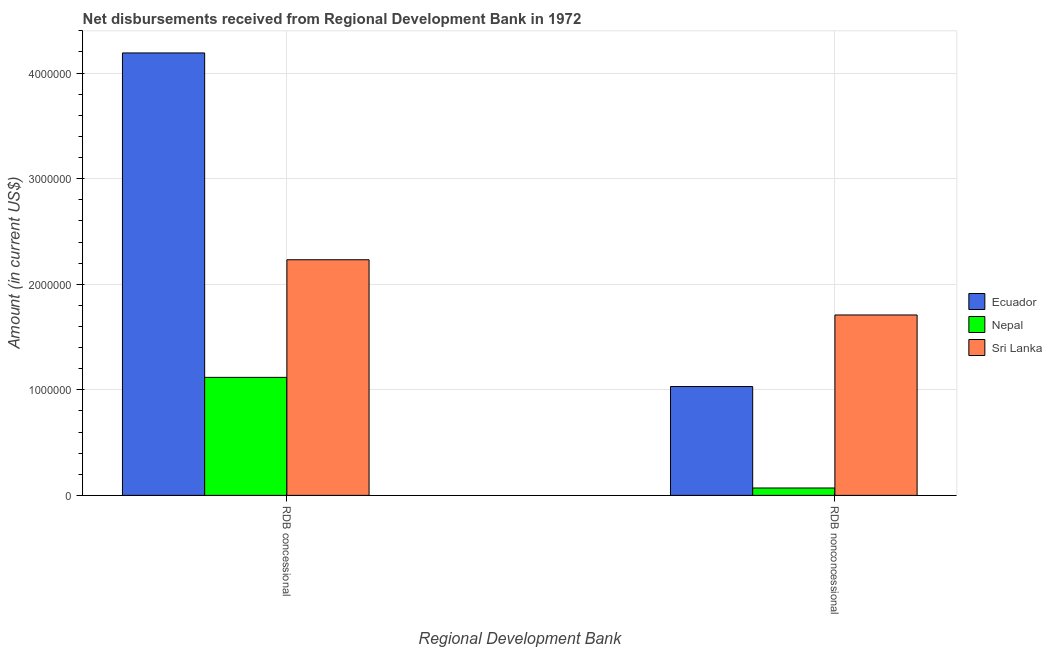How many different coloured bars are there?
Provide a short and direct response. 3. How many bars are there on the 2nd tick from the right?
Your response must be concise. 3. What is the label of the 1st group of bars from the left?
Your response must be concise. RDB concessional. What is the net non concessional disbursements from rdb in Sri Lanka?
Give a very brief answer. 1.71e+06. Across all countries, what is the maximum net concessional disbursements from rdb?
Offer a very short reply. 4.19e+06. Across all countries, what is the minimum net concessional disbursements from rdb?
Provide a short and direct response. 1.12e+06. In which country was the net non concessional disbursements from rdb maximum?
Your response must be concise. Sri Lanka. In which country was the net concessional disbursements from rdb minimum?
Offer a terse response. Nepal. What is the total net non concessional disbursements from rdb in the graph?
Provide a short and direct response. 2.81e+06. What is the difference between the net non concessional disbursements from rdb in Nepal and that in Ecuador?
Provide a succinct answer. -9.61e+05. What is the difference between the net concessional disbursements from rdb in Nepal and the net non concessional disbursements from rdb in Ecuador?
Make the answer very short. 8.70e+04. What is the average net non concessional disbursements from rdb per country?
Make the answer very short. 9.37e+05. What is the difference between the net non concessional disbursements from rdb and net concessional disbursements from rdb in Nepal?
Offer a terse response. -1.05e+06. What is the ratio of the net non concessional disbursements from rdb in Nepal to that in Sri Lanka?
Your answer should be very brief. 0.04. In how many countries, is the net concessional disbursements from rdb greater than the average net concessional disbursements from rdb taken over all countries?
Make the answer very short. 1. What does the 2nd bar from the left in RDB concessional represents?
Give a very brief answer. Nepal. What does the 1st bar from the right in RDB concessional represents?
Make the answer very short. Sri Lanka. Are all the bars in the graph horizontal?
Your response must be concise. No. How many countries are there in the graph?
Make the answer very short. 3. What is the difference between two consecutive major ticks on the Y-axis?
Your response must be concise. 1.00e+06. Does the graph contain any zero values?
Provide a succinct answer. No. Where does the legend appear in the graph?
Your response must be concise. Center right. How are the legend labels stacked?
Ensure brevity in your answer.  Vertical. What is the title of the graph?
Ensure brevity in your answer.  Net disbursements received from Regional Development Bank in 1972. Does "Small states" appear as one of the legend labels in the graph?
Offer a very short reply. No. What is the label or title of the X-axis?
Keep it short and to the point. Regional Development Bank. What is the label or title of the Y-axis?
Your answer should be compact. Amount (in current US$). What is the Amount (in current US$) in Ecuador in RDB concessional?
Provide a succinct answer. 4.19e+06. What is the Amount (in current US$) of Nepal in RDB concessional?
Offer a very short reply. 1.12e+06. What is the Amount (in current US$) of Sri Lanka in RDB concessional?
Your answer should be compact. 2.23e+06. What is the Amount (in current US$) of Ecuador in RDB nonconcessional?
Keep it short and to the point. 1.03e+06. What is the Amount (in current US$) in Sri Lanka in RDB nonconcessional?
Keep it short and to the point. 1.71e+06. Across all Regional Development Bank, what is the maximum Amount (in current US$) of Ecuador?
Provide a succinct answer. 4.19e+06. Across all Regional Development Bank, what is the maximum Amount (in current US$) of Nepal?
Provide a succinct answer. 1.12e+06. Across all Regional Development Bank, what is the maximum Amount (in current US$) in Sri Lanka?
Ensure brevity in your answer.  2.23e+06. Across all Regional Development Bank, what is the minimum Amount (in current US$) of Ecuador?
Provide a succinct answer. 1.03e+06. Across all Regional Development Bank, what is the minimum Amount (in current US$) in Sri Lanka?
Keep it short and to the point. 1.71e+06. What is the total Amount (in current US$) in Ecuador in the graph?
Offer a very short reply. 5.22e+06. What is the total Amount (in current US$) in Nepal in the graph?
Provide a short and direct response. 1.19e+06. What is the total Amount (in current US$) in Sri Lanka in the graph?
Offer a very short reply. 3.94e+06. What is the difference between the Amount (in current US$) of Ecuador in RDB concessional and that in RDB nonconcessional?
Offer a very short reply. 3.16e+06. What is the difference between the Amount (in current US$) of Nepal in RDB concessional and that in RDB nonconcessional?
Keep it short and to the point. 1.05e+06. What is the difference between the Amount (in current US$) of Sri Lanka in RDB concessional and that in RDB nonconcessional?
Ensure brevity in your answer.  5.23e+05. What is the difference between the Amount (in current US$) in Ecuador in RDB concessional and the Amount (in current US$) in Nepal in RDB nonconcessional?
Ensure brevity in your answer.  4.12e+06. What is the difference between the Amount (in current US$) of Ecuador in RDB concessional and the Amount (in current US$) of Sri Lanka in RDB nonconcessional?
Make the answer very short. 2.48e+06. What is the difference between the Amount (in current US$) of Nepal in RDB concessional and the Amount (in current US$) of Sri Lanka in RDB nonconcessional?
Keep it short and to the point. -5.91e+05. What is the average Amount (in current US$) in Ecuador per Regional Development Bank?
Offer a very short reply. 2.61e+06. What is the average Amount (in current US$) of Nepal per Regional Development Bank?
Ensure brevity in your answer.  5.94e+05. What is the average Amount (in current US$) of Sri Lanka per Regional Development Bank?
Your answer should be compact. 1.97e+06. What is the difference between the Amount (in current US$) of Ecuador and Amount (in current US$) of Nepal in RDB concessional?
Your response must be concise. 3.07e+06. What is the difference between the Amount (in current US$) in Ecuador and Amount (in current US$) in Sri Lanka in RDB concessional?
Keep it short and to the point. 1.96e+06. What is the difference between the Amount (in current US$) of Nepal and Amount (in current US$) of Sri Lanka in RDB concessional?
Your answer should be compact. -1.11e+06. What is the difference between the Amount (in current US$) in Ecuador and Amount (in current US$) in Nepal in RDB nonconcessional?
Your answer should be compact. 9.61e+05. What is the difference between the Amount (in current US$) in Ecuador and Amount (in current US$) in Sri Lanka in RDB nonconcessional?
Provide a succinct answer. -6.78e+05. What is the difference between the Amount (in current US$) in Nepal and Amount (in current US$) in Sri Lanka in RDB nonconcessional?
Offer a terse response. -1.64e+06. What is the ratio of the Amount (in current US$) in Ecuador in RDB concessional to that in RDB nonconcessional?
Keep it short and to the point. 4.07. What is the ratio of the Amount (in current US$) of Nepal in RDB concessional to that in RDB nonconcessional?
Give a very brief answer. 15.97. What is the ratio of the Amount (in current US$) in Sri Lanka in RDB concessional to that in RDB nonconcessional?
Keep it short and to the point. 1.31. What is the difference between the highest and the second highest Amount (in current US$) of Ecuador?
Offer a terse response. 3.16e+06. What is the difference between the highest and the second highest Amount (in current US$) of Nepal?
Your answer should be compact. 1.05e+06. What is the difference between the highest and the second highest Amount (in current US$) of Sri Lanka?
Your response must be concise. 5.23e+05. What is the difference between the highest and the lowest Amount (in current US$) of Ecuador?
Provide a short and direct response. 3.16e+06. What is the difference between the highest and the lowest Amount (in current US$) of Nepal?
Give a very brief answer. 1.05e+06. What is the difference between the highest and the lowest Amount (in current US$) of Sri Lanka?
Provide a short and direct response. 5.23e+05. 